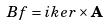Convert formula to latex. <formula><loc_0><loc_0><loc_500><loc_500>B f = i k e r \times \mathbf A</formula> 